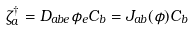Convert formula to latex. <formula><loc_0><loc_0><loc_500><loc_500>\zeta ^ { \dagger } _ { a } = D _ { a b e } \phi _ { e } C _ { b } = J _ { a b } ( \phi ) C _ { b }</formula> 